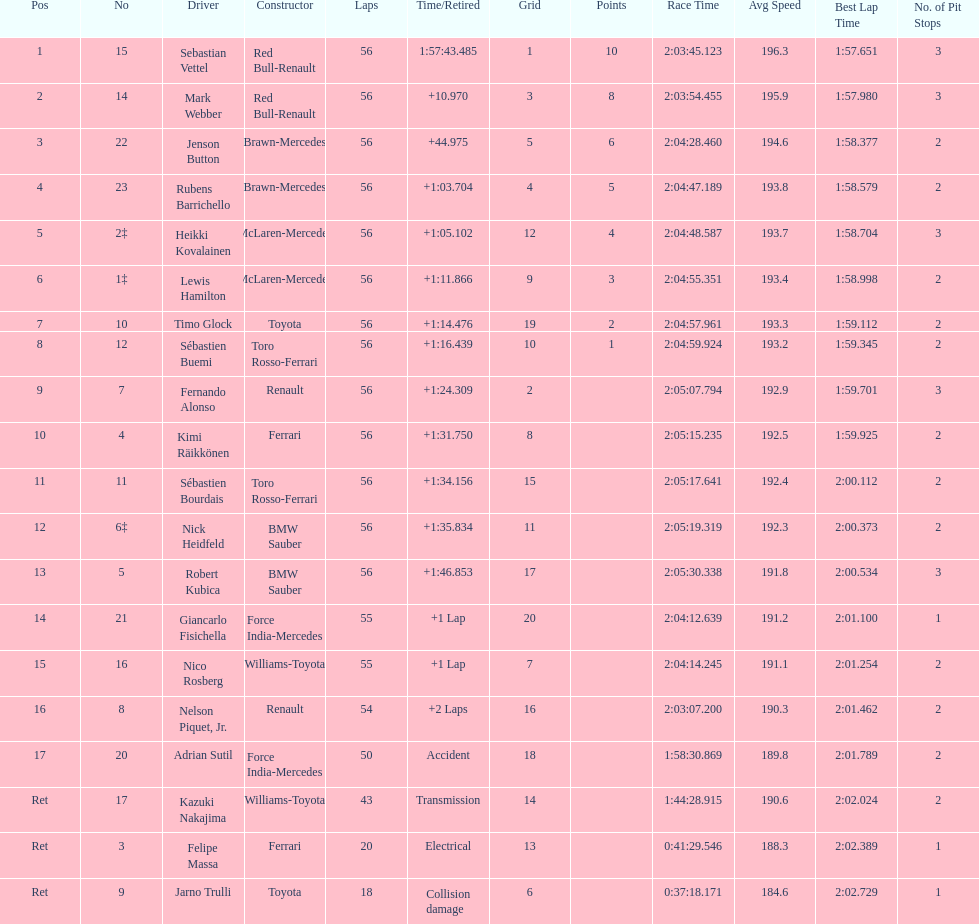What name is just previous to kazuki nakjima on the list? Adrian Sutil. 